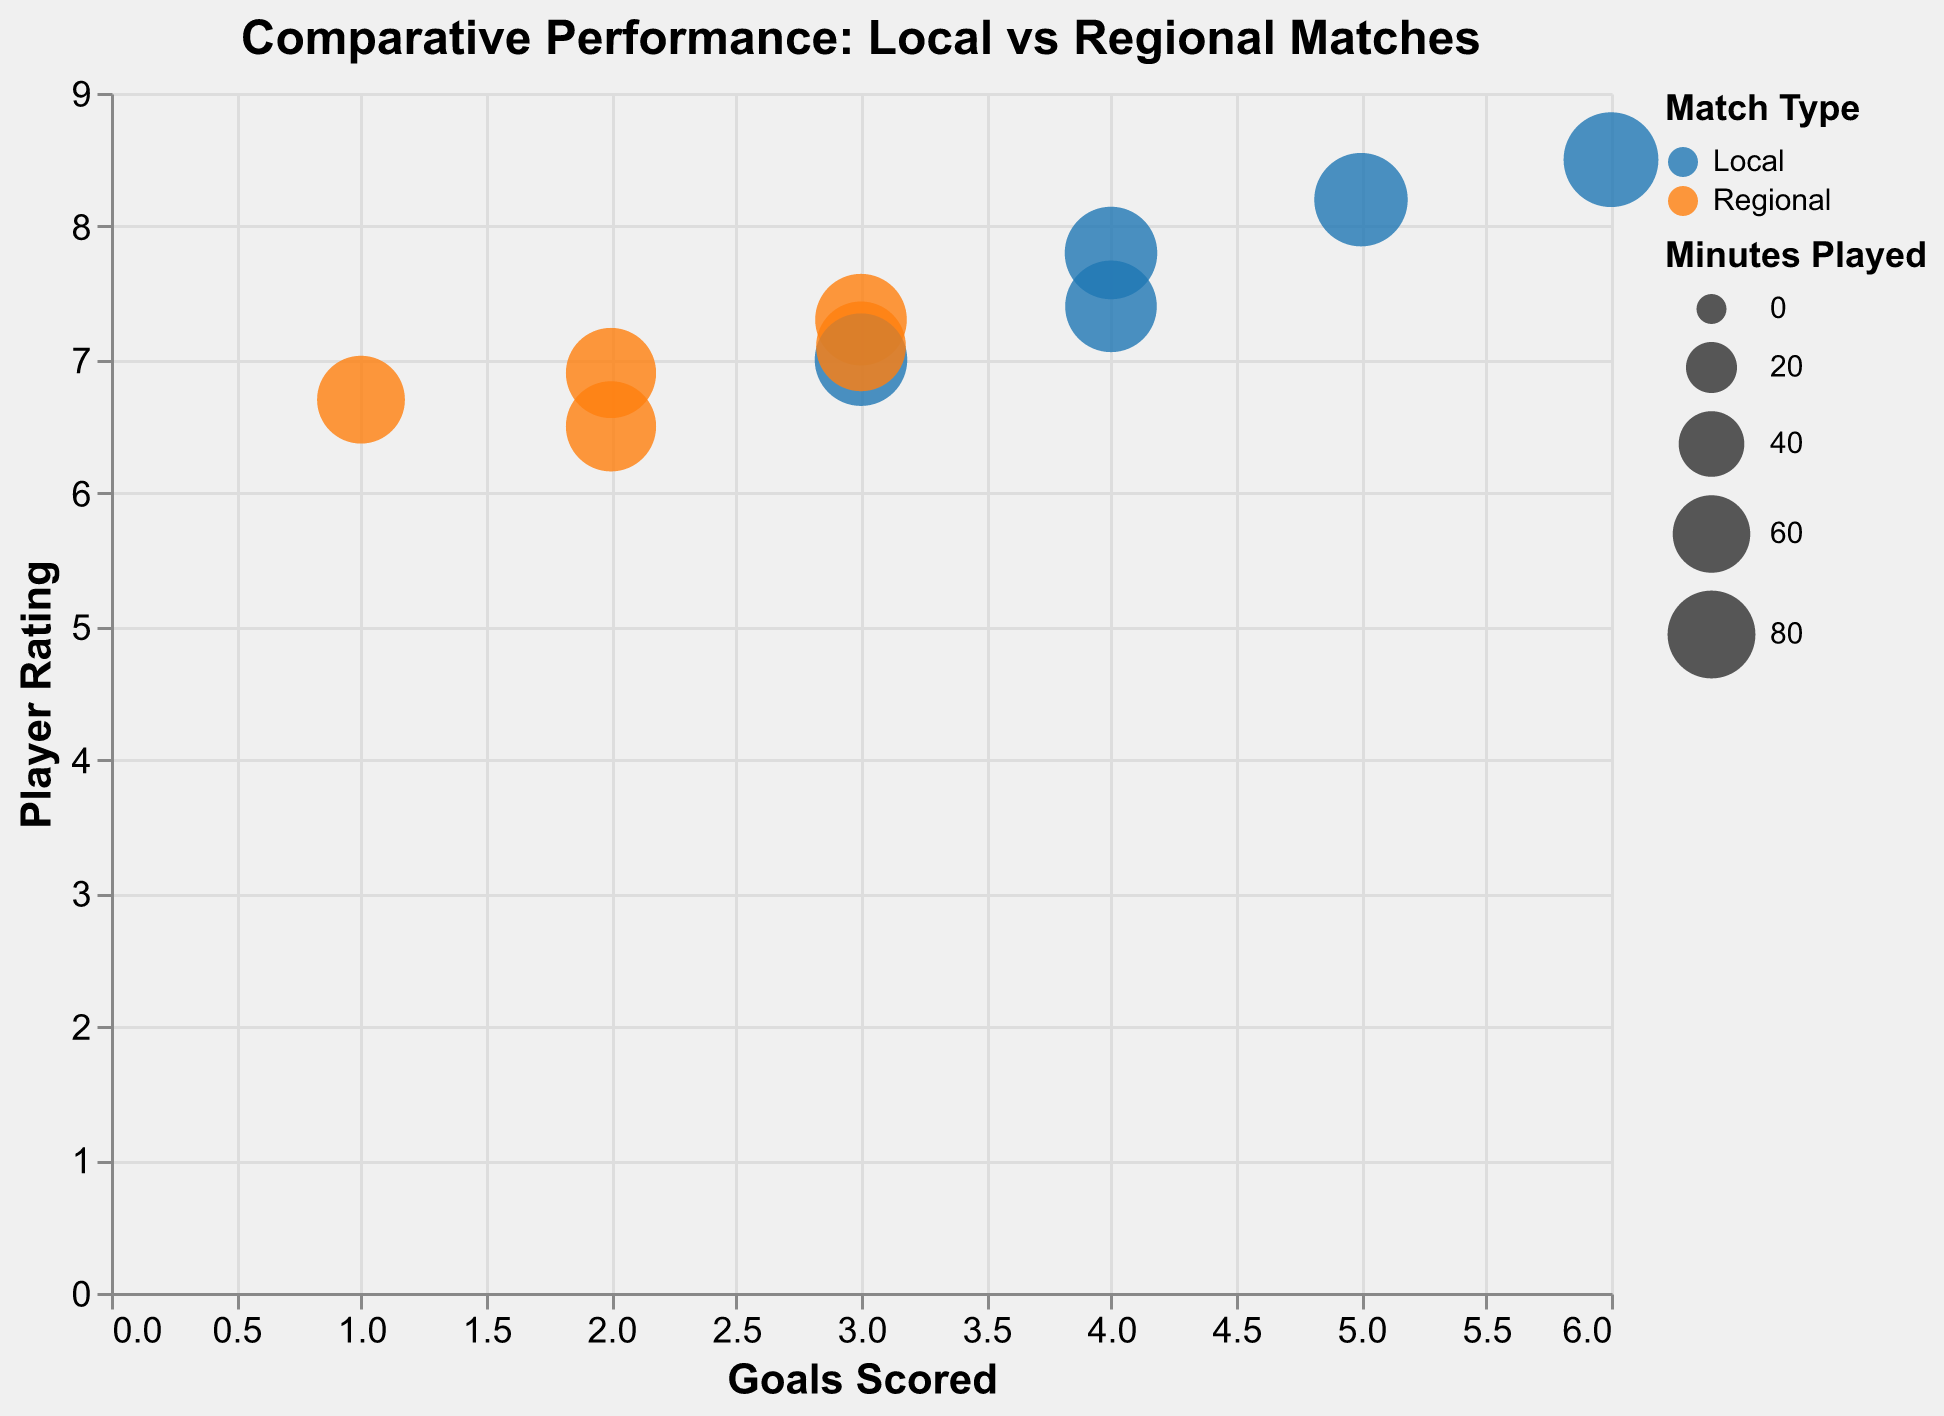What's the title of the chart? The title of the chart is displayed at the top. It reads "Comparative Performance: Local vs Regional Matches".
Answer: Comparative Performance: Local vs Regional Matches What do the colors in the chart represent? The colors in the chart represent the match types. Blue represents Local matches and orange represents Regional matches.
Answer: Match Type How many players participated in both Local and Regional matches? The tooltip feature shows each player's performance in Local and Regional matches. By looking at the different colored circles, you can count that each of the five players participated in both types of matches.
Answer: Five Which player had the highest Player Rating in Local matches? By examining the y-axis (Player Rating) values for the blue (Local) circles and finding the highest point, David Brown had the highest Player Rating of 8.5 in Local matches.
Answer: David Brown What is the average number of goals scored in Regional matches? There are 5 data points representing Regional matches. Summing the goals ((2 + 3 + 1 + 2 + 3) = 11) and dividing by the number of players (5), we get an average of 11/5 = 2.2 goals.
Answer: 2.2 Who played the most minutes in Regional matches and how many did they play? By checking the size of the orange circles, Michael Johnson's circle is the largest for Regional matches, indicating he played the most minutes, i.e., 88 minutes.
Answer: Michael Johnson, 88 minutes Compare the performance of John Smith in Local versus Regional matches in terms of Player Rating. John Smith's Local and Regional performance can be compared using the y-axis (Player Rating). His rating in Local matches is 7.8, while in Regional matches it is 6.9. Hence, his performance was better in Local matches.
Answer: Better in Local Which player had the most significant drop in Player Rating from Local to Regional matches? By comparing the difference in Player Rating for each player, David Brown had the largest drop from 8.5 in Local to 6.7 in Regional, a difference of 1.8.
Answer: David Brown How do James Wilson's goals compare between Local and Regional matches? James Wilson's goals can be compared by looking at the x-axis (Goals). For Local matches, he scored 3 goals, and for Regional matches, he scored 2 goals.
Answer: More in Local Which player had an equal number of assists in both Local and Regional matches? By looking at the tooltip for each player's data points, Robert Davis had 1 assist in both Local and Regional matches, indicating equal assists.
Answer: Robert Davis 